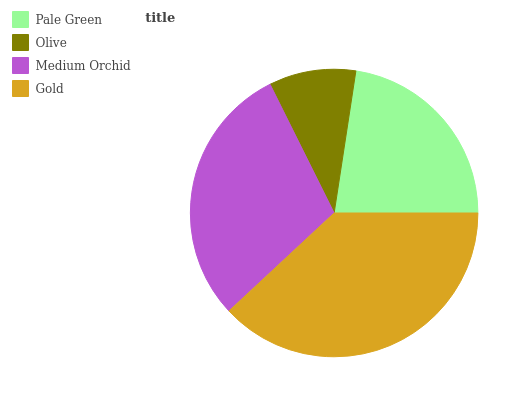Is Olive the minimum?
Answer yes or no. Yes. Is Gold the maximum?
Answer yes or no. Yes. Is Medium Orchid the minimum?
Answer yes or no. No. Is Medium Orchid the maximum?
Answer yes or no. No. Is Medium Orchid greater than Olive?
Answer yes or no. Yes. Is Olive less than Medium Orchid?
Answer yes or no. Yes. Is Olive greater than Medium Orchid?
Answer yes or no. No. Is Medium Orchid less than Olive?
Answer yes or no. No. Is Medium Orchid the high median?
Answer yes or no. Yes. Is Pale Green the low median?
Answer yes or no. Yes. Is Olive the high median?
Answer yes or no. No. Is Medium Orchid the low median?
Answer yes or no. No. 